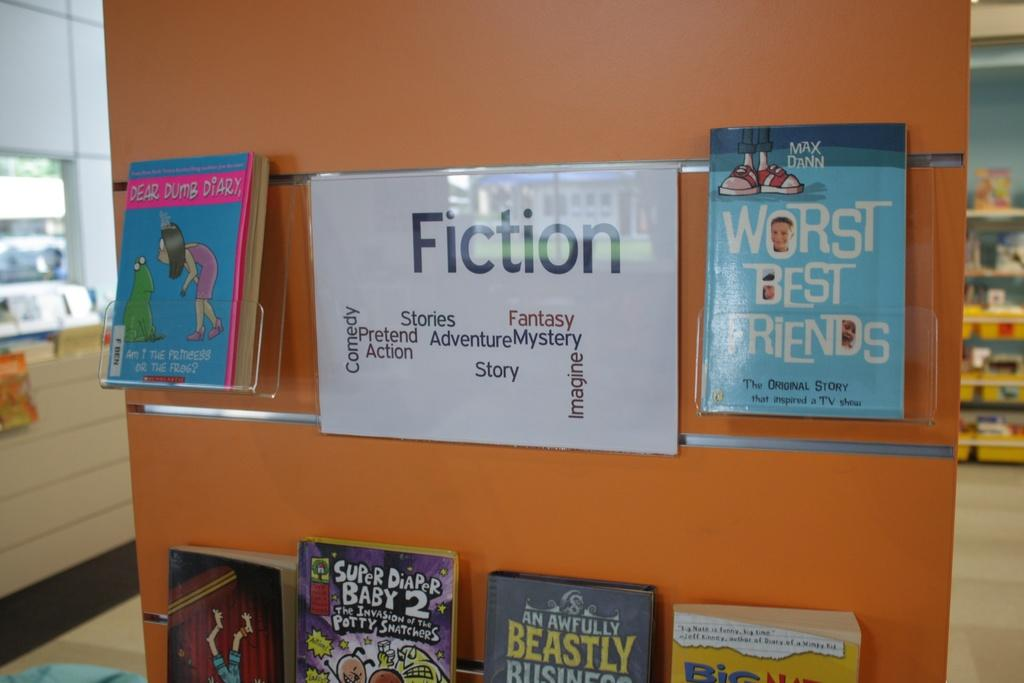<image>
Offer a succinct explanation of the picture presented. A fiction section of books sits in a library. 